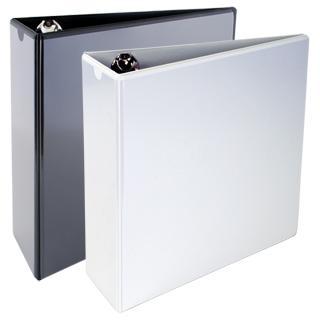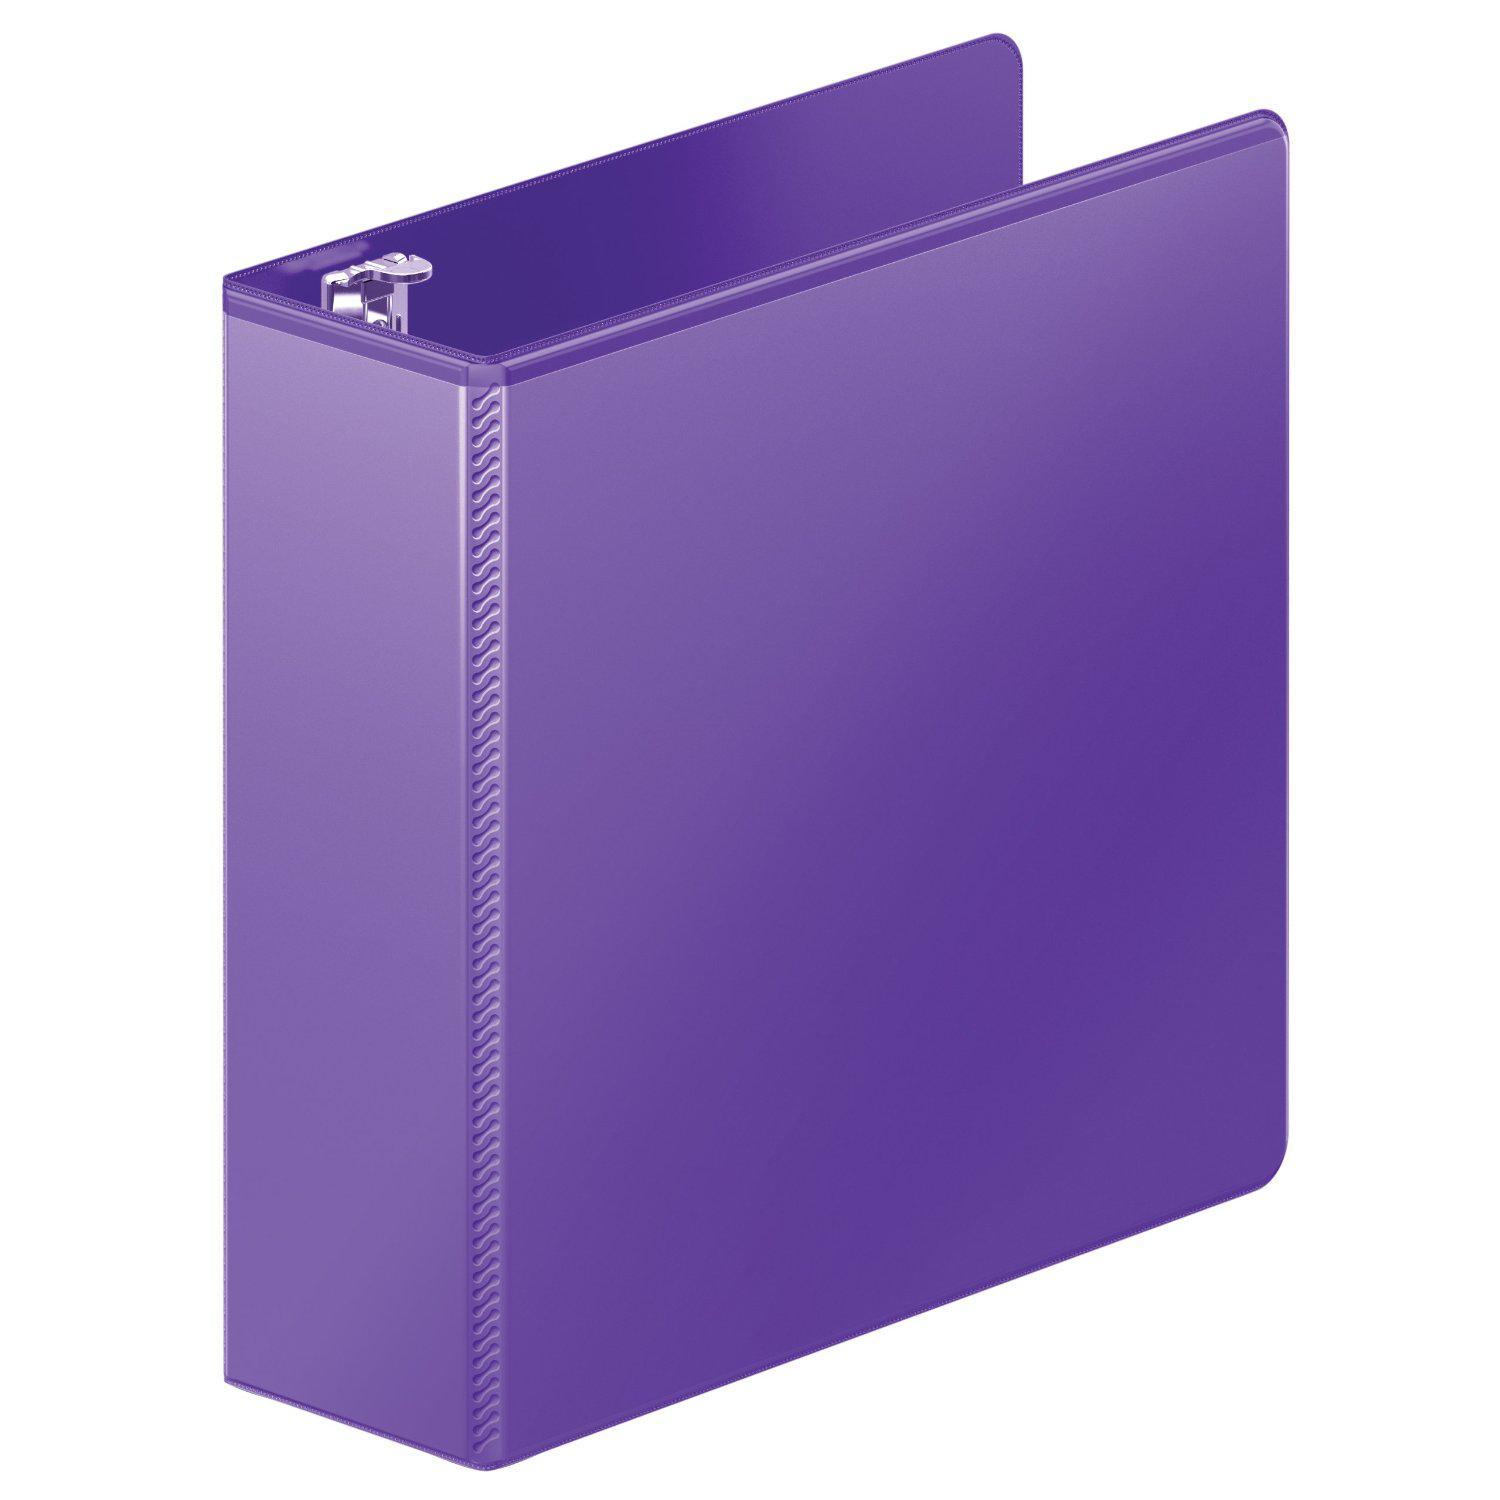The first image is the image on the left, the second image is the image on the right. Considering the images on both sides, is "The right image contains exactly one white binder standing vertically." valid? Answer yes or no. No. The first image is the image on the left, the second image is the image on the right. For the images shown, is this caption "There is a sticker on the spine of one of the binders." true? Answer yes or no. No. 